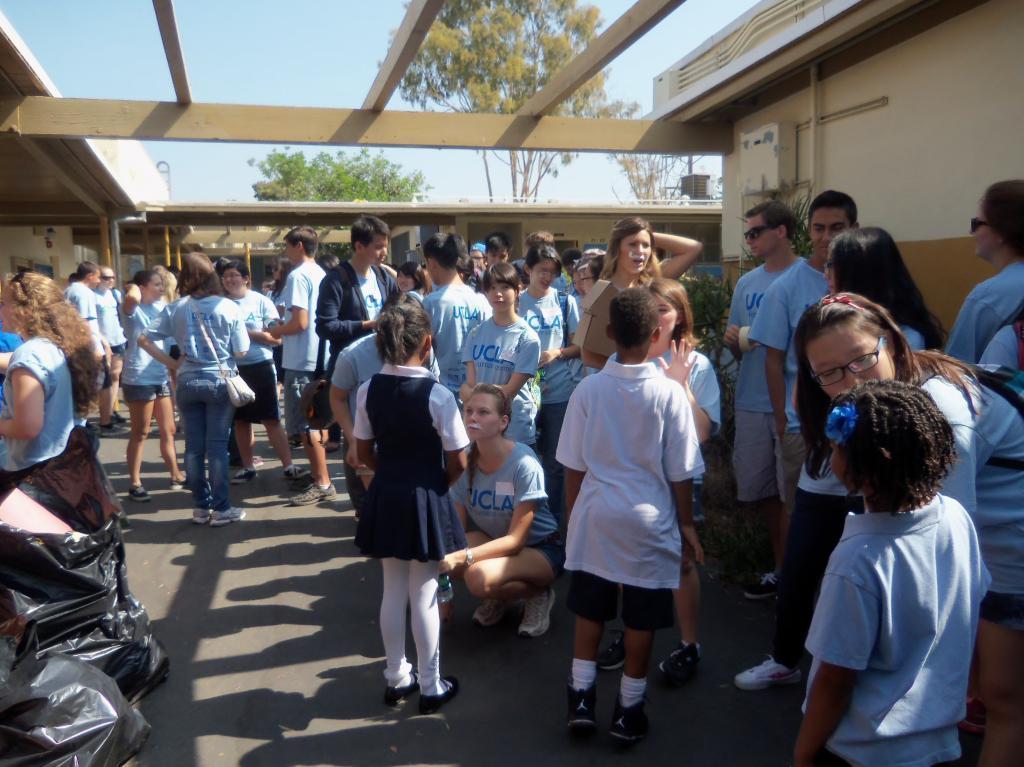Describe this image in one or two sentences. In this image I can see a group of people standing and wearing blue, white and navy blue color dresses. I can see few back color bags, buildings and trees. The sky is in blue color. 